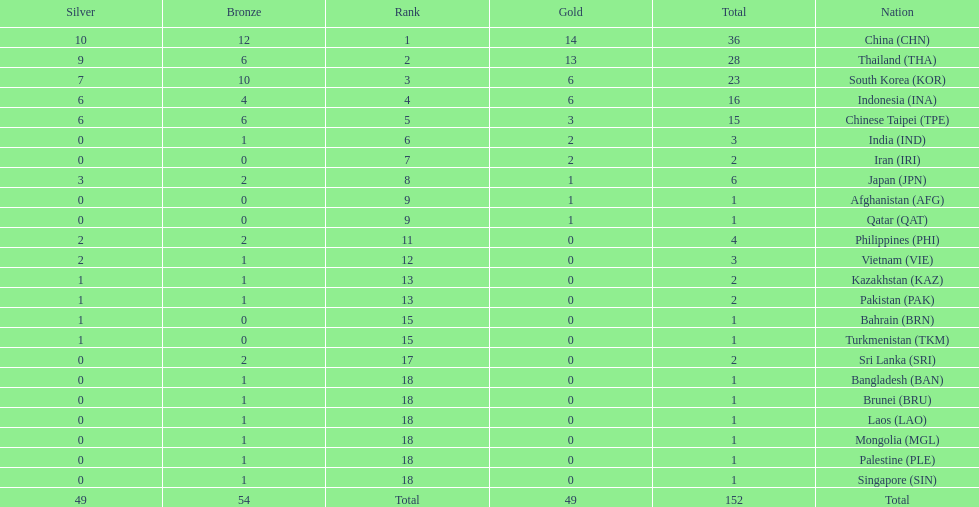Which countries won the same number of gold medals as japan? Afghanistan (AFG), Qatar (QAT). 